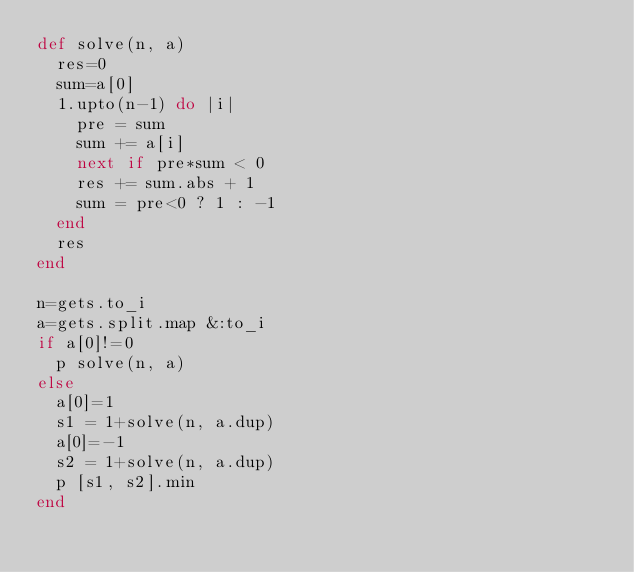Convert code to text. <code><loc_0><loc_0><loc_500><loc_500><_Ruby_>def solve(n, a)
  res=0
  sum=a[0]
  1.upto(n-1) do |i|
    pre = sum
    sum += a[i]
    next if pre*sum < 0
    res += sum.abs + 1
    sum = pre<0 ? 1 : -1
  end
  res
end

n=gets.to_i
a=gets.split.map &:to_i
if a[0]!=0
  p solve(n, a)
else
  a[0]=1
  s1 = 1+solve(n, a.dup)
  a[0]=-1
  s2 = 1+solve(n, a.dup)
  p [s1, s2].min
end
</code> 